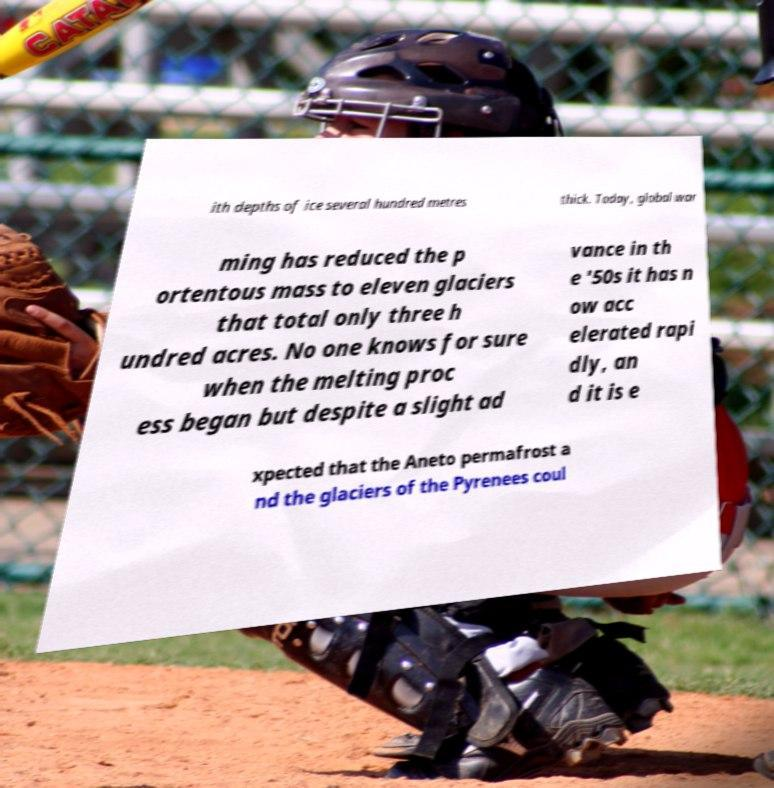I need the written content from this picture converted into text. Can you do that? ith depths of ice several hundred metres thick. Today, global war ming has reduced the p ortentous mass to eleven glaciers that total only three h undred acres. No one knows for sure when the melting proc ess began but despite a slight ad vance in th e '50s it has n ow acc elerated rapi dly, an d it is e xpected that the Aneto permafrost a nd the glaciers of the Pyrenees coul 